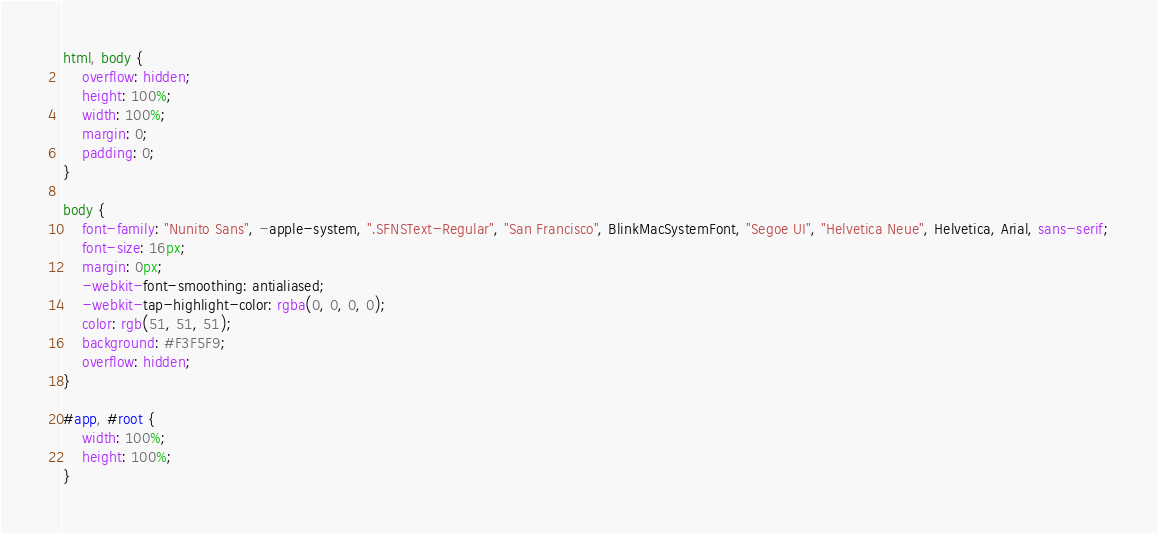<code> <loc_0><loc_0><loc_500><loc_500><_CSS_>html, body {
    overflow: hidden;
    height: 100%;
    width: 100%;
    margin: 0;
    padding: 0;
}

body {
    font-family: "Nunito Sans", -apple-system, ".SFNSText-Regular", "San Francisco", BlinkMacSystemFont, "Segoe UI", "Helvetica Neue", Helvetica, Arial, sans-serif;
    font-size: 16px;
    margin: 0px;
    -webkit-font-smoothing: antialiased;
    -webkit-tap-highlight-color: rgba(0, 0, 0, 0);
    color: rgb(51, 51, 51);
    background: #F3F5F9;
    overflow: hidden;
}

#app, #root {
    width: 100%;
    height: 100%;
}</code> 